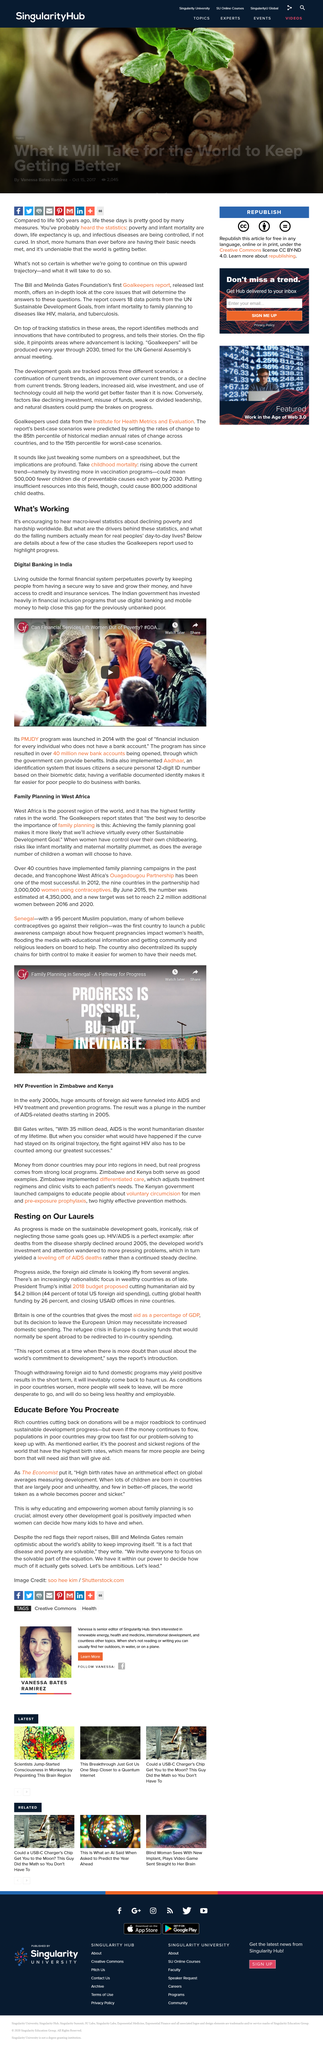Point out several critical features in this image. The Indian government has invested heavily in financial inclusion programs, making it a prominent leader in this area. A report that utilizes case studies to showcase the decline of poverty, known as the 'Goalkeepers' report, highlights the progress made in achieving the U.N.'s Sustainable Development Goals. Digital banking and mobile money have proven to be effective financial inclusion programs that have helped to close the gap for the previously unbanked poor. These programs have enabled individuals who were previously excluded from traditional banking services to access financial services and facilitate financial transactions through digital means. 